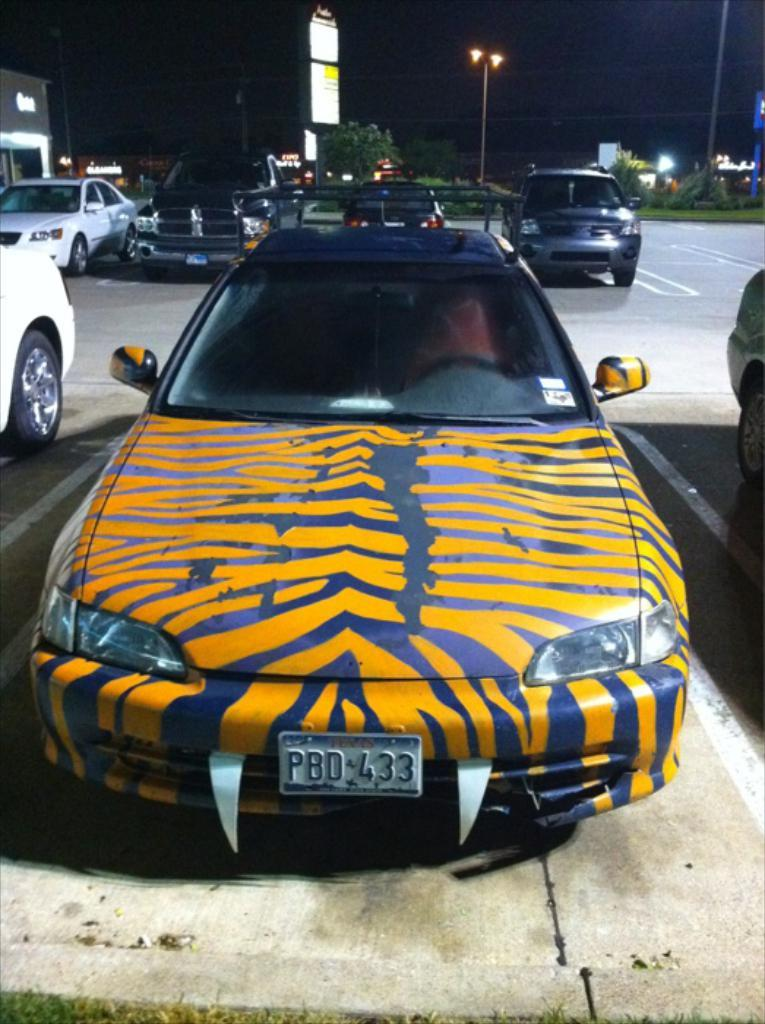<image>
Share a concise interpretation of the image provided. A car with a Texas license plate has yellow stripes. 